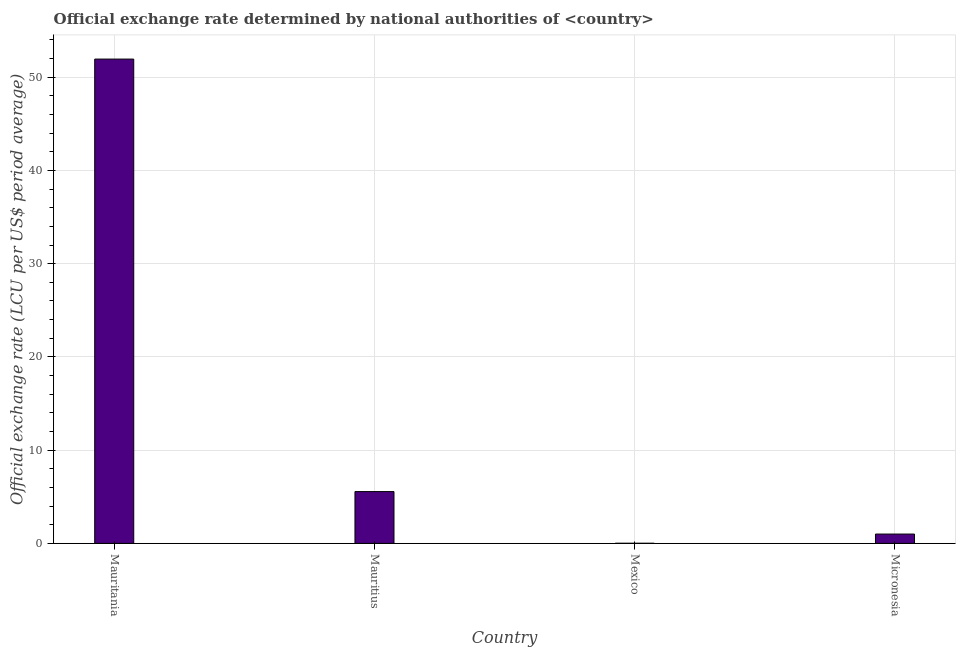Does the graph contain any zero values?
Your answer should be compact. No. Does the graph contain grids?
Keep it short and to the point. Yes. What is the title of the graph?
Your response must be concise. Official exchange rate determined by national authorities of <country>. What is the label or title of the X-axis?
Give a very brief answer. Country. What is the label or title of the Y-axis?
Ensure brevity in your answer.  Official exchange rate (LCU per US$ period average). What is the official exchange rate in Micronesia?
Offer a very short reply. 1. Across all countries, what is the maximum official exchange rate?
Ensure brevity in your answer.  51.94. Across all countries, what is the minimum official exchange rate?
Your answer should be very brief. 0.01. In which country was the official exchange rate maximum?
Your response must be concise. Mauritania. What is the sum of the official exchange rate?
Make the answer very short. 58.51. What is the difference between the official exchange rate in Mauritania and Micronesia?
Your answer should be compact. 50.94. What is the average official exchange rate per country?
Your answer should be very brief. 14.63. What is the median official exchange rate?
Offer a terse response. 3.28. In how many countries, is the official exchange rate greater than 44 ?
Your response must be concise. 1. What is the ratio of the official exchange rate in Mauritania to that in Mauritius?
Make the answer very short. 9.35. Is the difference between the official exchange rate in Mauritius and Mexico greater than the difference between any two countries?
Your answer should be very brief. No. What is the difference between the highest and the second highest official exchange rate?
Ensure brevity in your answer.  46.39. Is the sum of the official exchange rate in Mauritania and Mexico greater than the maximum official exchange rate across all countries?
Your answer should be very brief. Yes. What is the difference between the highest and the lowest official exchange rate?
Make the answer very short. 51.93. In how many countries, is the official exchange rate greater than the average official exchange rate taken over all countries?
Ensure brevity in your answer.  1. How many bars are there?
Your answer should be compact. 4. How many countries are there in the graph?
Offer a very short reply. 4. What is the Official exchange rate (LCU per US$ period average) of Mauritania?
Your answer should be very brief. 51.94. What is the Official exchange rate (LCU per US$ period average) of Mauritius?
Offer a very short reply. 5.56. What is the Official exchange rate (LCU per US$ period average) in Mexico?
Your answer should be very brief. 0.01. What is the difference between the Official exchange rate (LCU per US$ period average) in Mauritania and Mauritius?
Make the answer very short. 46.39. What is the difference between the Official exchange rate (LCU per US$ period average) in Mauritania and Mexico?
Your answer should be very brief. 51.93. What is the difference between the Official exchange rate (LCU per US$ period average) in Mauritania and Micronesia?
Make the answer very short. 50.94. What is the difference between the Official exchange rate (LCU per US$ period average) in Mauritius and Mexico?
Offer a terse response. 5.54. What is the difference between the Official exchange rate (LCU per US$ period average) in Mauritius and Micronesia?
Your response must be concise. 4.56. What is the difference between the Official exchange rate (LCU per US$ period average) in Mexico and Micronesia?
Your response must be concise. -0.99. What is the ratio of the Official exchange rate (LCU per US$ period average) in Mauritania to that in Mauritius?
Offer a very short reply. 9.35. What is the ratio of the Official exchange rate (LCU per US$ period average) in Mauritania to that in Mexico?
Offer a very short reply. 4155.33. What is the ratio of the Official exchange rate (LCU per US$ period average) in Mauritania to that in Micronesia?
Your response must be concise. 51.94. What is the ratio of the Official exchange rate (LCU per US$ period average) in Mauritius to that in Mexico?
Provide a short and direct response. 444.44. What is the ratio of the Official exchange rate (LCU per US$ period average) in Mauritius to that in Micronesia?
Provide a short and direct response. 5.56. What is the ratio of the Official exchange rate (LCU per US$ period average) in Mexico to that in Micronesia?
Ensure brevity in your answer.  0.01. 